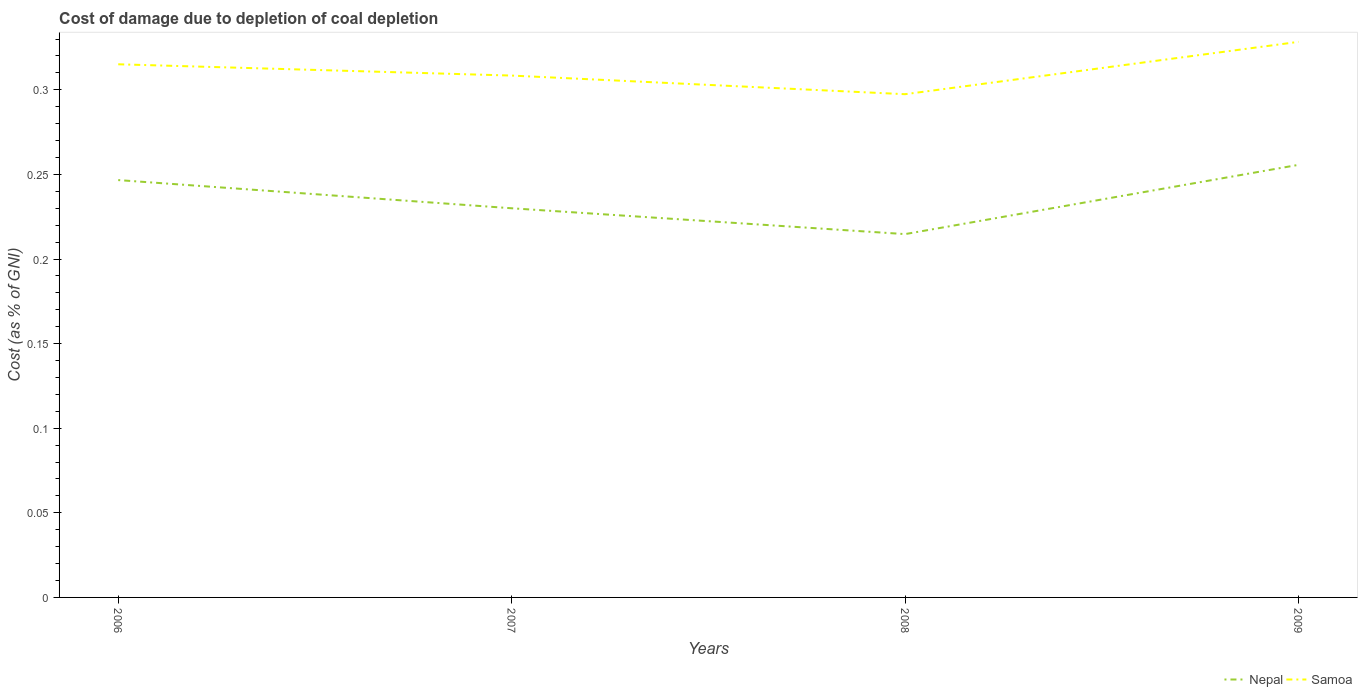Is the number of lines equal to the number of legend labels?
Your answer should be very brief. Yes. Across all years, what is the maximum cost of damage caused due to coal depletion in Nepal?
Make the answer very short. 0.21. In which year was the cost of damage caused due to coal depletion in Samoa maximum?
Provide a short and direct response. 2008. What is the total cost of damage caused due to coal depletion in Samoa in the graph?
Your answer should be very brief. -0.01. What is the difference between the highest and the second highest cost of damage caused due to coal depletion in Nepal?
Make the answer very short. 0.04. Is the cost of damage caused due to coal depletion in Samoa strictly greater than the cost of damage caused due to coal depletion in Nepal over the years?
Make the answer very short. No. How many years are there in the graph?
Your answer should be very brief. 4. Are the values on the major ticks of Y-axis written in scientific E-notation?
Offer a terse response. No. Does the graph contain any zero values?
Make the answer very short. No. Where does the legend appear in the graph?
Ensure brevity in your answer.  Bottom right. What is the title of the graph?
Offer a terse response. Cost of damage due to depletion of coal depletion. Does "Cyprus" appear as one of the legend labels in the graph?
Ensure brevity in your answer.  No. What is the label or title of the X-axis?
Your answer should be compact. Years. What is the label or title of the Y-axis?
Ensure brevity in your answer.  Cost (as % of GNI). What is the Cost (as % of GNI) in Nepal in 2006?
Your answer should be compact. 0.25. What is the Cost (as % of GNI) of Samoa in 2006?
Provide a short and direct response. 0.32. What is the Cost (as % of GNI) in Nepal in 2007?
Your answer should be very brief. 0.23. What is the Cost (as % of GNI) of Samoa in 2007?
Offer a terse response. 0.31. What is the Cost (as % of GNI) in Nepal in 2008?
Offer a terse response. 0.21. What is the Cost (as % of GNI) of Samoa in 2008?
Your response must be concise. 0.3. What is the Cost (as % of GNI) of Nepal in 2009?
Your answer should be compact. 0.26. What is the Cost (as % of GNI) in Samoa in 2009?
Your answer should be very brief. 0.33. Across all years, what is the maximum Cost (as % of GNI) in Nepal?
Ensure brevity in your answer.  0.26. Across all years, what is the maximum Cost (as % of GNI) of Samoa?
Ensure brevity in your answer.  0.33. Across all years, what is the minimum Cost (as % of GNI) of Nepal?
Ensure brevity in your answer.  0.21. Across all years, what is the minimum Cost (as % of GNI) in Samoa?
Your answer should be very brief. 0.3. What is the total Cost (as % of GNI) of Nepal in the graph?
Provide a short and direct response. 0.95. What is the total Cost (as % of GNI) in Samoa in the graph?
Keep it short and to the point. 1.25. What is the difference between the Cost (as % of GNI) in Nepal in 2006 and that in 2007?
Provide a short and direct response. 0.02. What is the difference between the Cost (as % of GNI) of Samoa in 2006 and that in 2007?
Make the answer very short. 0.01. What is the difference between the Cost (as % of GNI) of Nepal in 2006 and that in 2008?
Give a very brief answer. 0.03. What is the difference between the Cost (as % of GNI) of Samoa in 2006 and that in 2008?
Provide a short and direct response. 0.02. What is the difference between the Cost (as % of GNI) in Nepal in 2006 and that in 2009?
Provide a short and direct response. -0.01. What is the difference between the Cost (as % of GNI) of Samoa in 2006 and that in 2009?
Offer a very short reply. -0.01. What is the difference between the Cost (as % of GNI) of Nepal in 2007 and that in 2008?
Your answer should be very brief. 0.02. What is the difference between the Cost (as % of GNI) of Samoa in 2007 and that in 2008?
Offer a terse response. 0.01. What is the difference between the Cost (as % of GNI) in Nepal in 2007 and that in 2009?
Your response must be concise. -0.03. What is the difference between the Cost (as % of GNI) in Samoa in 2007 and that in 2009?
Provide a short and direct response. -0.02. What is the difference between the Cost (as % of GNI) of Nepal in 2008 and that in 2009?
Your answer should be compact. -0.04. What is the difference between the Cost (as % of GNI) of Samoa in 2008 and that in 2009?
Make the answer very short. -0.03. What is the difference between the Cost (as % of GNI) in Nepal in 2006 and the Cost (as % of GNI) in Samoa in 2007?
Your answer should be very brief. -0.06. What is the difference between the Cost (as % of GNI) in Nepal in 2006 and the Cost (as % of GNI) in Samoa in 2008?
Offer a terse response. -0.05. What is the difference between the Cost (as % of GNI) in Nepal in 2006 and the Cost (as % of GNI) in Samoa in 2009?
Give a very brief answer. -0.08. What is the difference between the Cost (as % of GNI) in Nepal in 2007 and the Cost (as % of GNI) in Samoa in 2008?
Provide a short and direct response. -0.07. What is the difference between the Cost (as % of GNI) of Nepal in 2007 and the Cost (as % of GNI) of Samoa in 2009?
Make the answer very short. -0.1. What is the difference between the Cost (as % of GNI) of Nepal in 2008 and the Cost (as % of GNI) of Samoa in 2009?
Your answer should be very brief. -0.11. What is the average Cost (as % of GNI) of Nepal per year?
Provide a succinct answer. 0.24. What is the average Cost (as % of GNI) of Samoa per year?
Give a very brief answer. 0.31. In the year 2006, what is the difference between the Cost (as % of GNI) in Nepal and Cost (as % of GNI) in Samoa?
Provide a short and direct response. -0.07. In the year 2007, what is the difference between the Cost (as % of GNI) of Nepal and Cost (as % of GNI) of Samoa?
Your answer should be compact. -0.08. In the year 2008, what is the difference between the Cost (as % of GNI) of Nepal and Cost (as % of GNI) of Samoa?
Offer a terse response. -0.08. In the year 2009, what is the difference between the Cost (as % of GNI) in Nepal and Cost (as % of GNI) in Samoa?
Your answer should be compact. -0.07. What is the ratio of the Cost (as % of GNI) of Nepal in 2006 to that in 2007?
Give a very brief answer. 1.07. What is the ratio of the Cost (as % of GNI) in Samoa in 2006 to that in 2007?
Your answer should be compact. 1.02. What is the ratio of the Cost (as % of GNI) in Nepal in 2006 to that in 2008?
Ensure brevity in your answer.  1.15. What is the ratio of the Cost (as % of GNI) of Samoa in 2006 to that in 2008?
Provide a short and direct response. 1.06. What is the ratio of the Cost (as % of GNI) in Nepal in 2006 to that in 2009?
Offer a very short reply. 0.96. What is the ratio of the Cost (as % of GNI) in Samoa in 2006 to that in 2009?
Ensure brevity in your answer.  0.96. What is the ratio of the Cost (as % of GNI) of Nepal in 2007 to that in 2008?
Keep it short and to the point. 1.07. What is the ratio of the Cost (as % of GNI) in Nepal in 2007 to that in 2009?
Offer a very short reply. 0.9. What is the ratio of the Cost (as % of GNI) in Samoa in 2007 to that in 2009?
Make the answer very short. 0.94. What is the ratio of the Cost (as % of GNI) in Nepal in 2008 to that in 2009?
Keep it short and to the point. 0.84. What is the ratio of the Cost (as % of GNI) of Samoa in 2008 to that in 2009?
Your answer should be very brief. 0.91. What is the difference between the highest and the second highest Cost (as % of GNI) in Nepal?
Keep it short and to the point. 0.01. What is the difference between the highest and the second highest Cost (as % of GNI) of Samoa?
Provide a succinct answer. 0.01. What is the difference between the highest and the lowest Cost (as % of GNI) of Nepal?
Your answer should be very brief. 0.04. What is the difference between the highest and the lowest Cost (as % of GNI) of Samoa?
Provide a short and direct response. 0.03. 